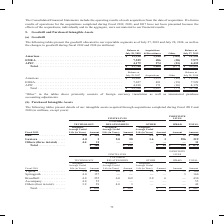From Cisco Systems's financial document, Which years does the table provide information for the goodwill associated to the company's reportable segments? The document shows two values: 2019 and 2018. From the document: "isitions & Divestitures Other Balance at July 27, 2019 Americas . $ 19,998 $ 1,240 $ (118) $ 21,120 EMEA . 7,529 486 (38) 7,977 APJC . 4,179 274 (21) ..." Also, What does Other primarily consist of? foreign currency translation as well as immaterial purchase accounting adjustments.. The document states: "“Other” in the tables above primarily consists of foreign currency translation as well as immaterial purchase accounting adjustments...." Also, What was the Total balance at July 28, 2018? According to the financial document, 31,706 (in millions). The relevant text states: "(38) 7,977 APJC . 4,179 274 (21) 4,432 Total . $ 31,706 $ 2,000 $ (177) $ 33,529..." Also, can you calculate: What was the change in balance from Americas between 2018 and 2019? Based on the calculation: 21,120-19,998, the result is 1122 (in millions). This is based on the information: "ly 27, 2019 Americas . $ 19,998 $ 1,240 $ (118) $ 21,120 EMEA . 7,529 486 (38) 7,977 APJC . 4,179 274 (21) 4,432 Total . $ 31,706 $ 2,000 $ (177) $ 33,529 tures Other Balance at July 27, 2019 Americas..." The key data points involved are: 19,998, 21,120. Additionally, What was the region with the highest  Acquisitions & Divestitures? According to the financial document, Americas. The relevant text states: "ons & Divestitures Other Balance at July 27, 2019 Americas . $ 19,998 $ 1,240 $ (118) $ 21,120 EMEA . 7,529 486 (38) 7,977 APJC . 4,179 274 (21) 4,432 Total ...." Also, can you calculate: What was the percentage change in the total balance between 2018 and 2019? To answer this question, I need to perform calculations using the financial data. The calculation is: (33,529-31,706)/31,706, which equals 5.75 (percentage). This is based on the information: "274 (21) 4,432 Total . $ 31,706 $ 2,000 $ (177) $ 33,529 (38) 7,977 APJC . 4,179 274 (21) 4,432 Total . $ 31,706 $ 2,000 $ (177) $ 33,529..." The key data points involved are: 31,706, 33,529. 